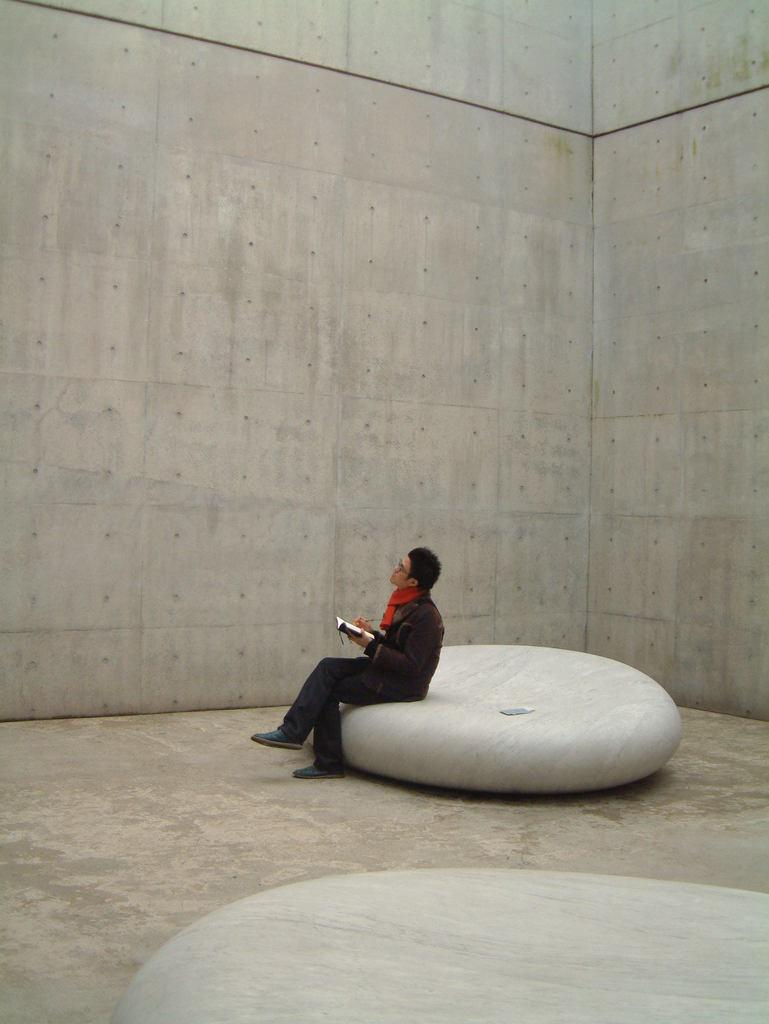Who is present in the image? There is a man in the image. What is the man doing in the image? The man is sitting on a white object. What can be seen in the background of the image? There is a wall in the image. Are there any other objects visible in the image? Yes, there are other objects in the image. What type of shoes is the man wearing in the image? There is no information about the man's shoes in the image, so we cannot determine what type he is wearing. 